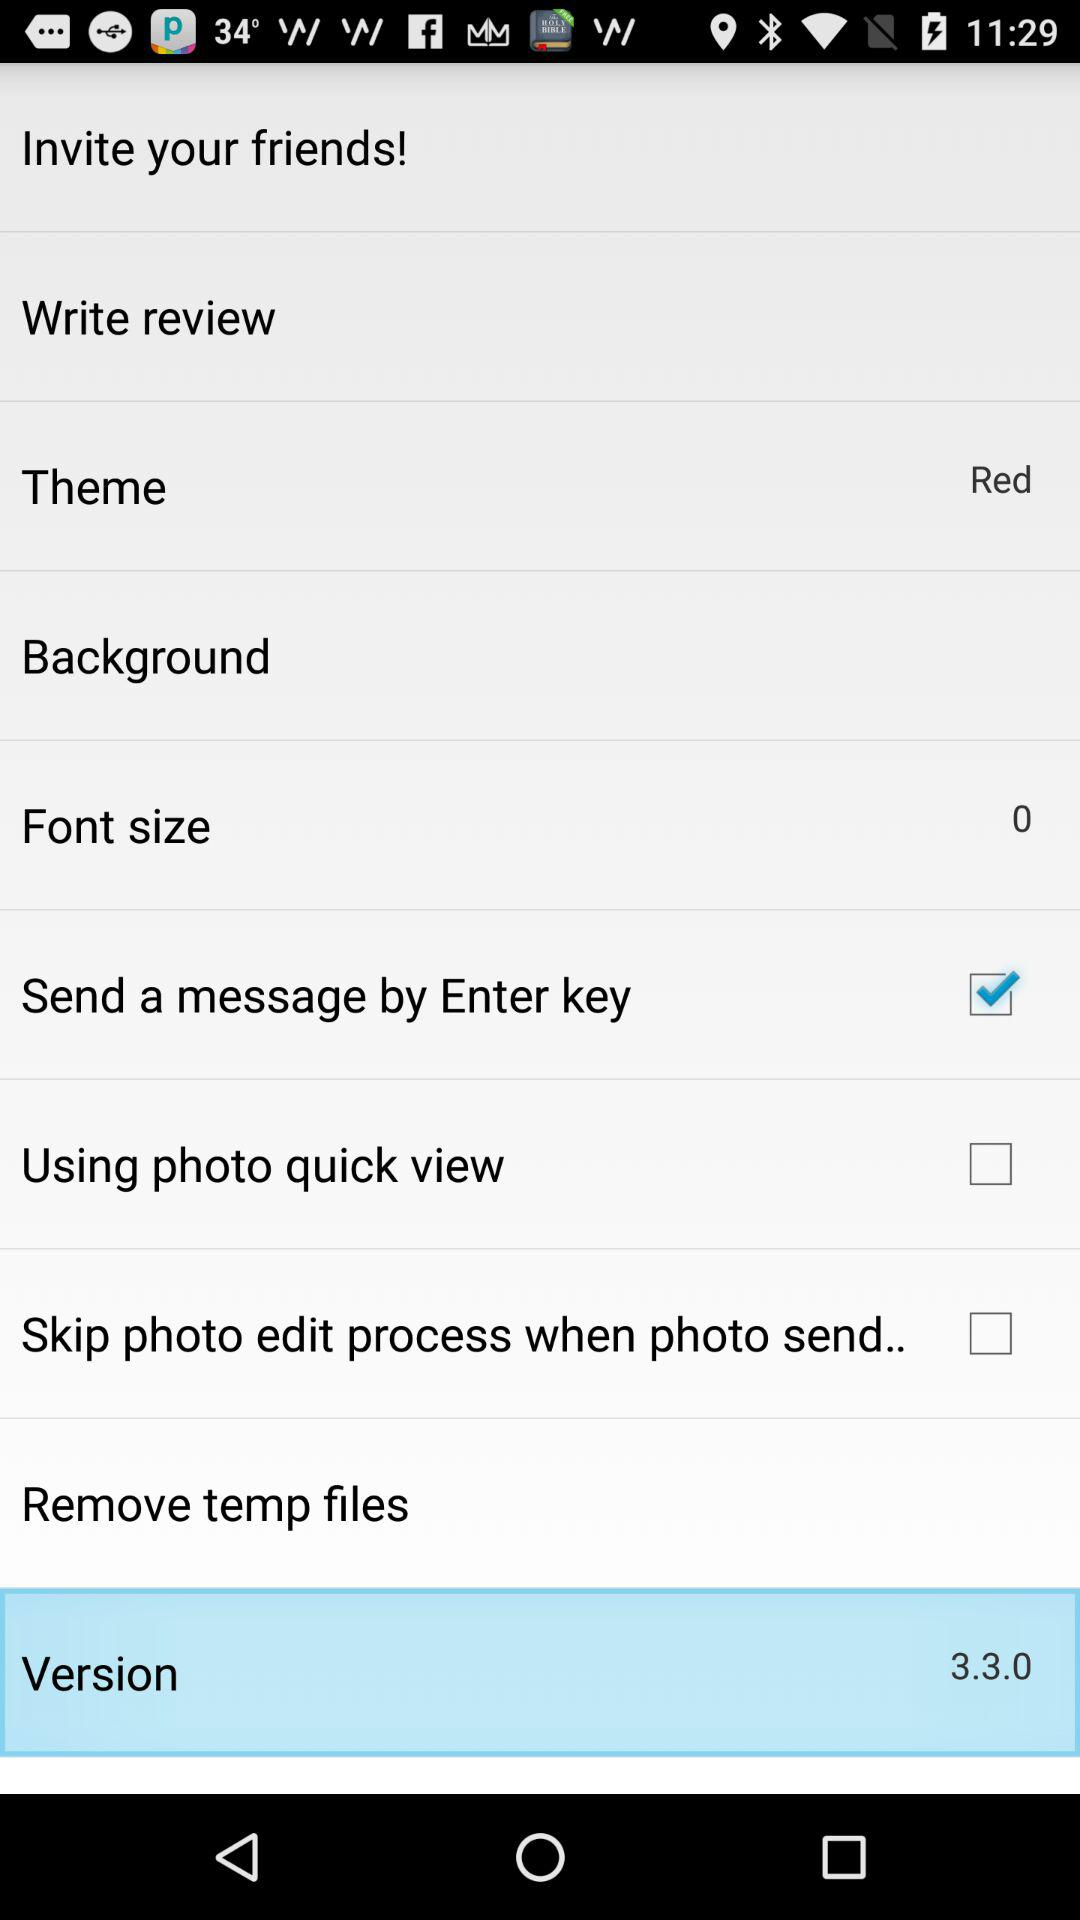What is the font size? The font size is 0. 